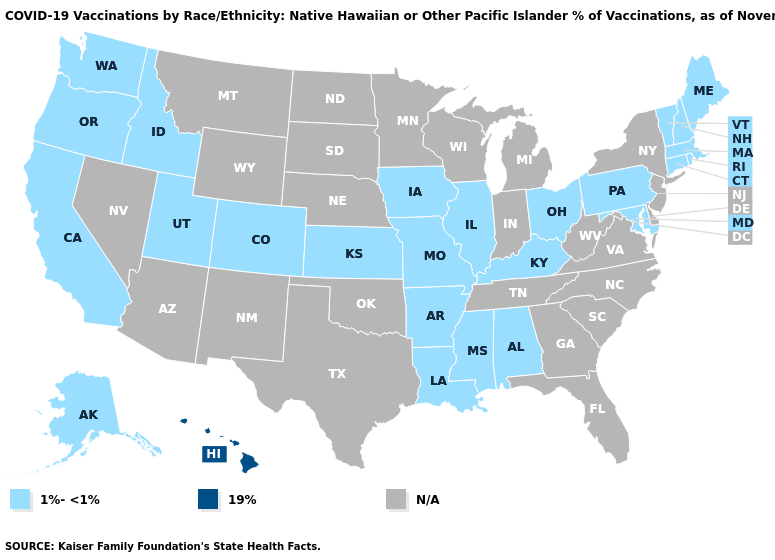What is the value of New Mexico?
Give a very brief answer. N/A. Is the legend a continuous bar?
Give a very brief answer. No. Does the map have missing data?
Give a very brief answer. Yes. What is the value of Virginia?
Short answer required. N/A. What is the value of New Mexico?
Short answer required. N/A. What is the value of New Jersey?
Keep it brief. N/A. Does Ohio have the highest value in the USA?
Keep it brief. No. Does the first symbol in the legend represent the smallest category?
Answer briefly. Yes. Name the states that have a value in the range 1%-<1%?
Give a very brief answer. Alabama, Alaska, Arkansas, California, Colorado, Connecticut, Idaho, Illinois, Iowa, Kansas, Kentucky, Louisiana, Maine, Maryland, Massachusetts, Mississippi, Missouri, New Hampshire, Ohio, Oregon, Pennsylvania, Rhode Island, Utah, Vermont, Washington. What is the highest value in the USA?
Be succinct. 19%. Name the states that have a value in the range N/A?
Answer briefly. Arizona, Delaware, Florida, Georgia, Indiana, Michigan, Minnesota, Montana, Nebraska, Nevada, New Jersey, New Mexico, New York, North Carolina, North Dakota, Oklahoma, South Carolina, South Dakota, Tennessee, Texas, Virginia, West Virginia, Wisconsin, Wyoming. Which states hav the highest value in the Northeast?
Be succinct. Connecticut, Maine, Massachusetts, New Hampshire, Pennsylvania, Rhode Island, Vermont. Does the first symbol in the legend represent the smallest category?
Keep it brief. Yes. 